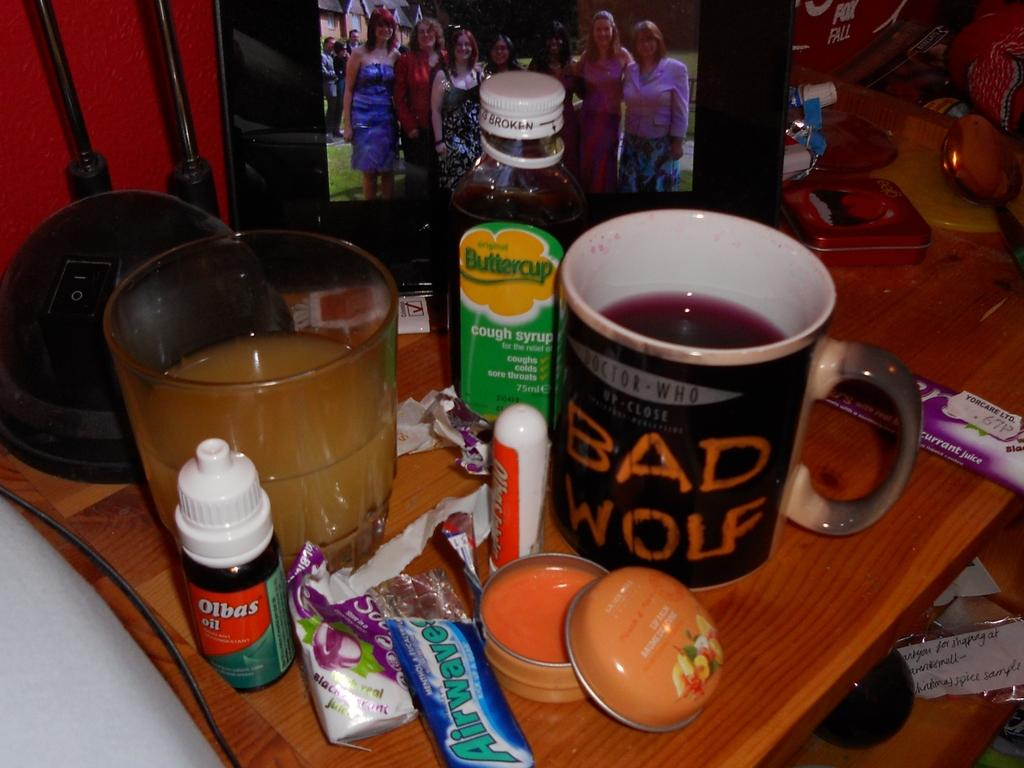<image>
Relay a brief, clear account of the picture shown. The person who owns this cup must be a fan of Doctor Who. 